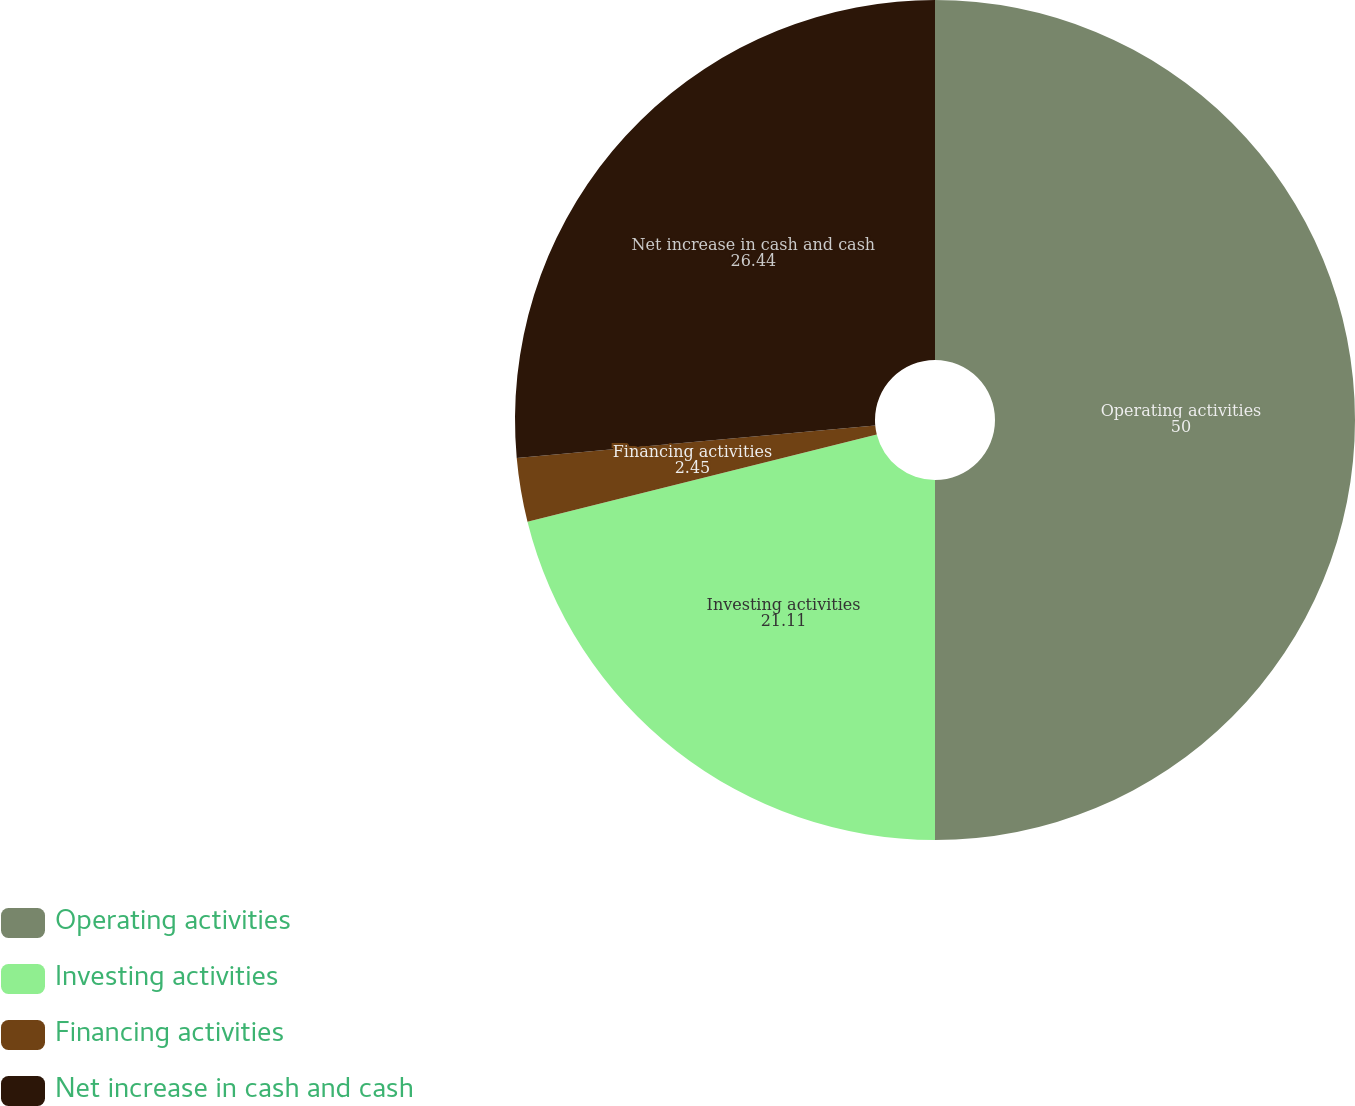Convert chart to OTSL. <chart><loc_0><loc_0><loc_500><loc_500><pie_chart><fcel>Operating activities<fcel>Investing activities<fcel>Financing activities<fcel>Net increase in cash and cash<nl><fcel>50.0%<fcel>21.11%<fcel>2.45%<fcel>26.44%<nl></chart> 